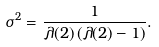<formula> <loc_0><loc_0><loc_500><loc_500>\sigma ^ { 2 } = \frac { 1 } { \lambda ( 2 ) \, ( \lambda ( 2 ) - 1 ) } .</formula> 